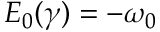Convert formula to latex. <formula><loc_0><loc_0><loc_500><loc_500>E _ { 0 } ( \gamma ) = - \omega _ { 0 }</formula> 